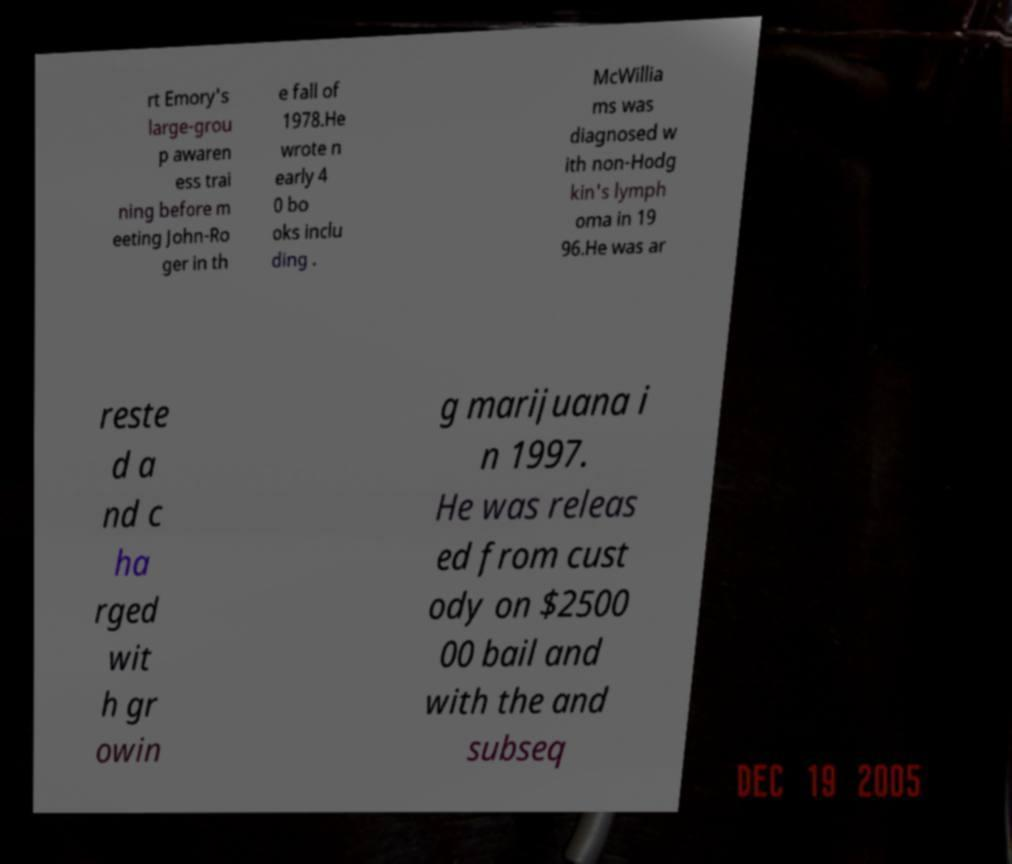I need the written content from this picture converted into text. Can you do that? rt Emory's large-grou p awaren ess trai ning before m eeting John-Ro ger in th e fall of 1978.He wrote n early 4 0 bo oks inclu ding . McWillia ms was diagnosed w ith non-Hodg kin's lymph oma in 19 96.He was ar reste d a nd c ha rged wit h gr owin g marijuana i n 1997. He was releas ed from cust ody on $2500 00 bail and with the and subseq 